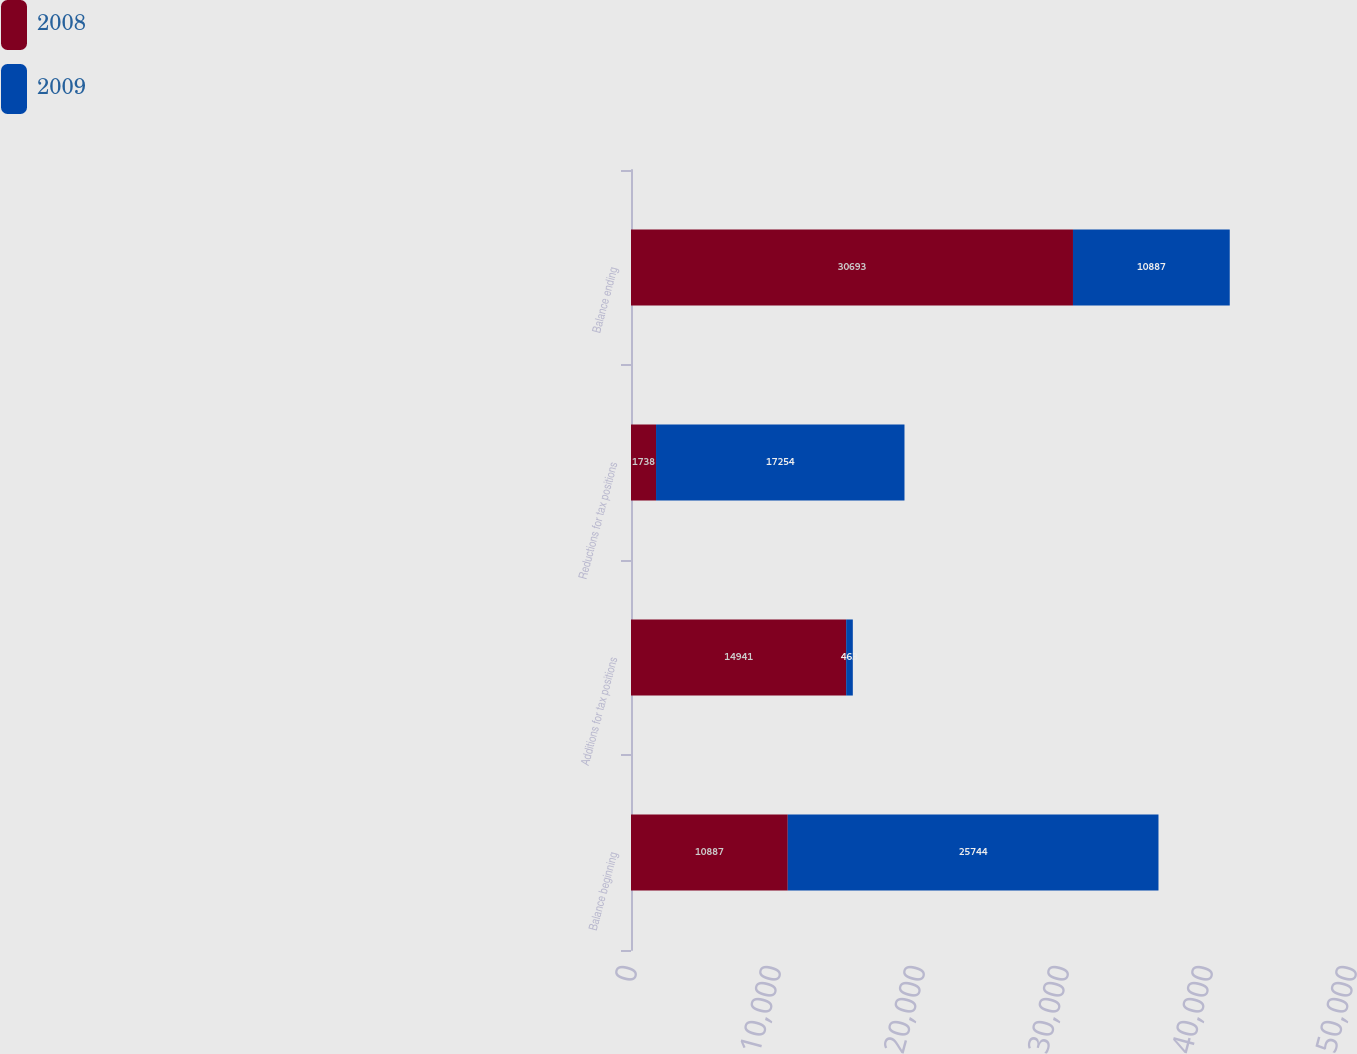Convert chart. <chart><loc_0><loc_0><loc_500><loc_500><stacked_bar_chart><ecel><fcel>Balance beginning<fcel>Additions for tax positions<fcel>Reductions for tax positions<fcel>Balance ending<nl><fcel>2008<fcel>10887<fcel>14941<fcel>1738<fcel>30693<nl><fcel>2009<fcel>25744<fcel>463<fcel>17254<fcel>10887<nl></chart> 